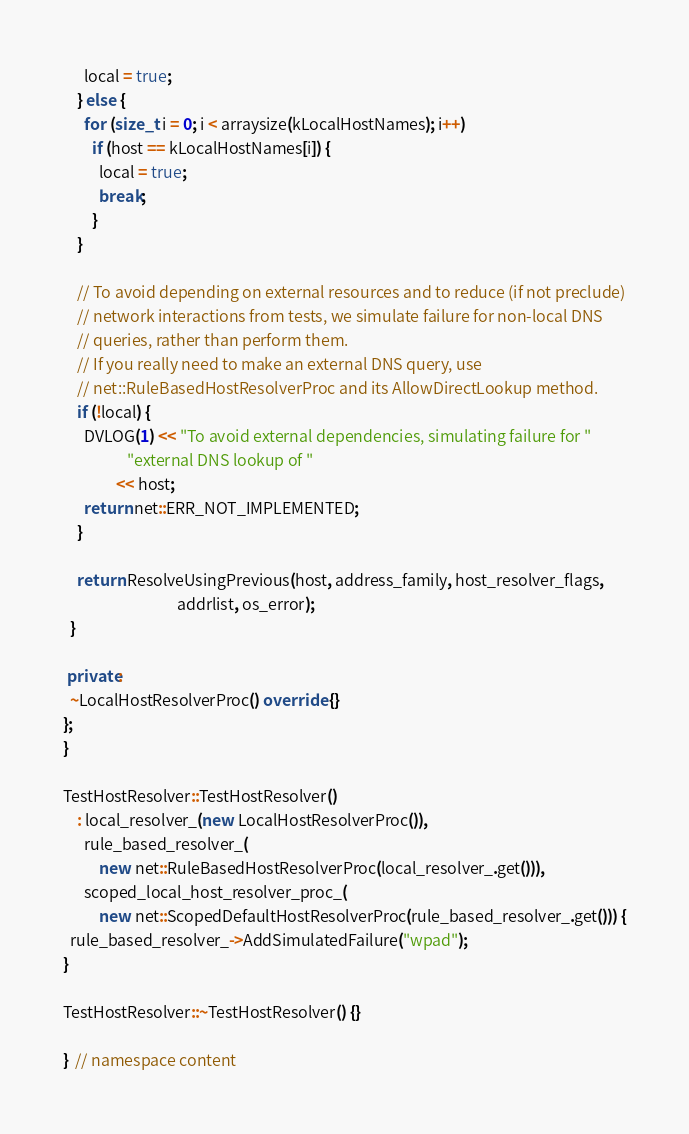<code> <loc_0><loc_0><loc_500><loc_500><_C++_>      local = true;
    } else {
      for (size_t i = 0; i < arraysize(kLocalHostNames); i++)
        if (host == kLocalHostNames[i]) {
          local = true;
          break;
        }
    }

    // To avoid depending on external resources and to reduce (if not preclude)
    // network interactions from tests, we simulate failure for non-local DNS
    // queries, rather than perform them.
    // If you really need to make an external DNS query, use
    // net::RuleBasedHostResolverProc and its AllowDirectLookup method.
    if (!local) {
      DVLOG(1) << "To avoid external dependencies, simulating failure for "
                  "external DNS lookup of "
               << host;
      return net::ERR_NOT_IMPLEMENTED;
    }

    return ResolveUsingPrevious(host, address_family, host_resolver_flags,
                                addrlist, os_error);
  }

 private:
  ~LocalHostResolverProc() override {}
};
}

TestHostResolver::TestHostResolver()
    : local_resolver_(new LocalHostResolverProc()),
      rule_based_resolver_(
          new net::RuleBasedHostResolverProc(local_resolver_.get())),
      scoped_local_host_resolver_proc_(
          new net::ScopedDefaultHostResolverProc(rule_based_resolver_.get())) {
  rule_based_resolver_->AddSimulatedFailure("wpad");
}

TestHostResolver::~TestHostResolver() {}

}  // namespace content
</code> 